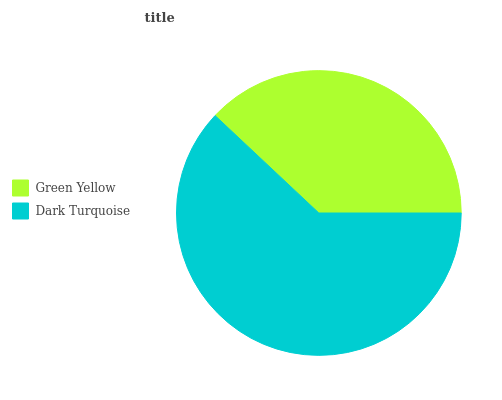Is Green Yellow the minimum?
Answer yes or no. Yes. Is Dark Turquoise the maximum?
Answer yes or no. Yes. Is Dark Turquoise the minimum?
Answer yes or no. No. Is Dark Turquoise greater than Green Yellow?
Answer yes or no. Yes. Is Green Yellow less than Dark Turquoise?
Answer yes or no. Yes. Is Green Yellow greater than Dark Turquoise?
Answer yes or no. No. Is Dark Turquoise less than Green Yellow?
Answer yes or no. No. Is Dark Turquoise the high median?
Answer yes or no. Yes. Is Green Yellow the low median?
Answer yes or no. Yes. Is Green Yellow the high median?
Answer yes or no. No. Is Dark Turquoise the low median?
Answer yes or no. No. 